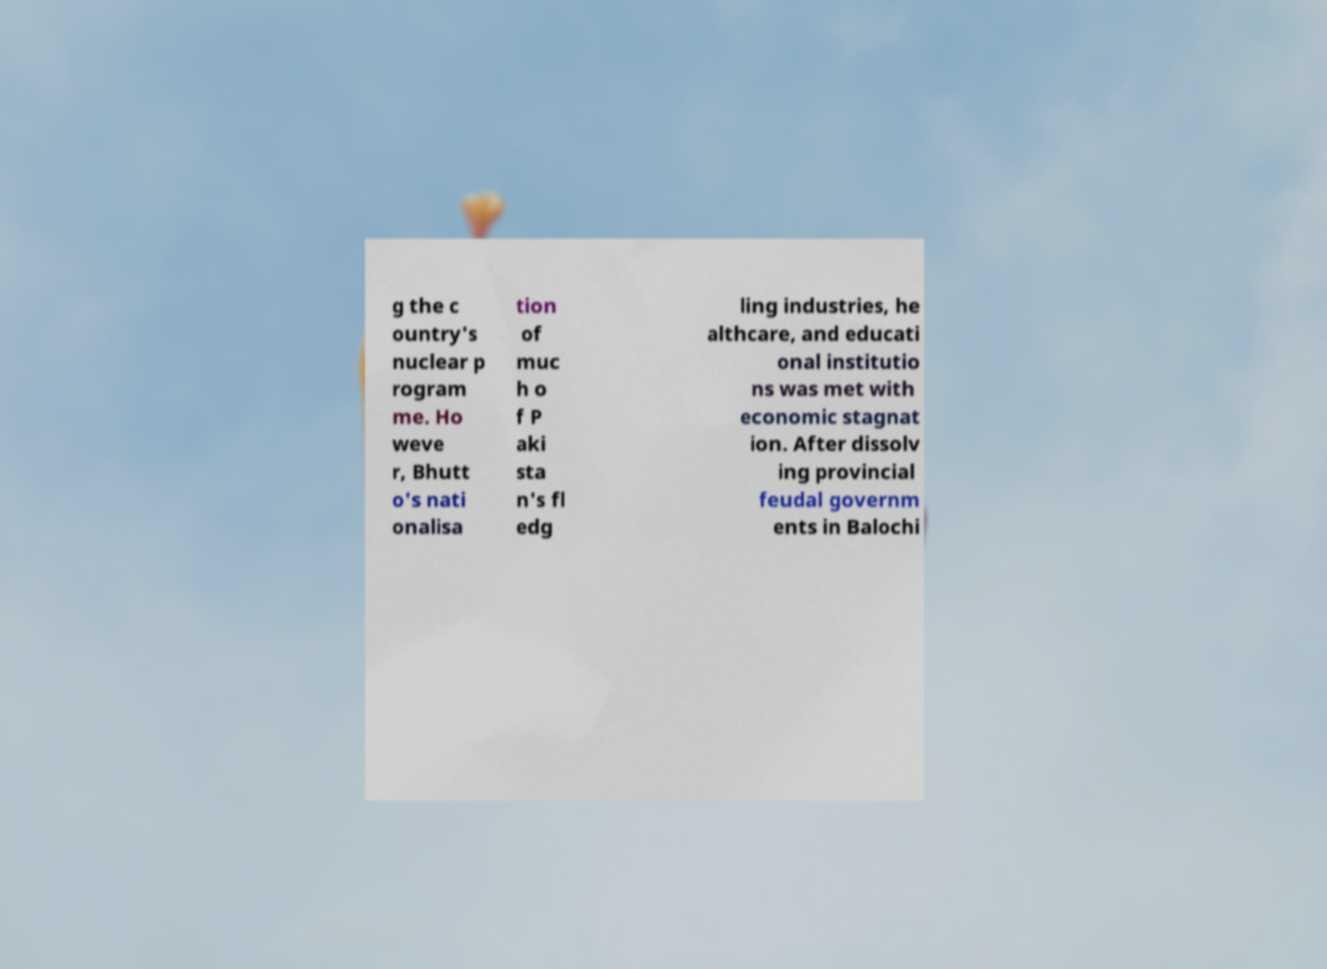Can you accurately transcribe the text from the provided image for me? g the c ountry's nuclear p rogram me. Ho weve r, Bhutt o's nati onalisa tion of muc h o f P aki sta n's fl edg ling industries, he althcare, and educati onal institutio ns was met with economic stagnat ion. After dissolv ing provincial feudal governm ents in Balochi 